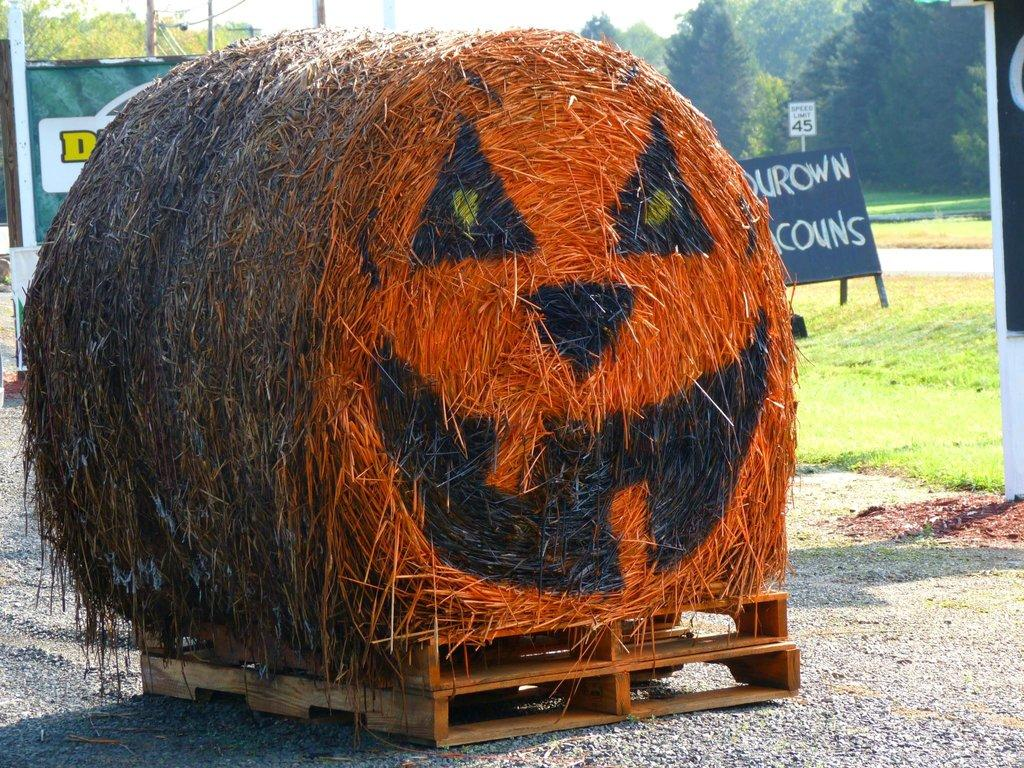What is located on the wooden box in the foreground? There is a grass roll on a wooden box in the foreground. What type of vegetation can be seen in the background? There is grass in the background. What other objects can be seen in the background? There are boards, posters, and trees in the background. What part of the natural environment is visible in the background? The sky is visible in the background. Based on the visible sky, when do you think the image was taken? The image was likely taken during the day, as the sky appears bright and not dark. How does the grass roll affect the quality of sleep in the image? The grass roll does not affect the quality of sleep in the image, as there is no indication of anyone sleeping or being affected by the grass roll. 